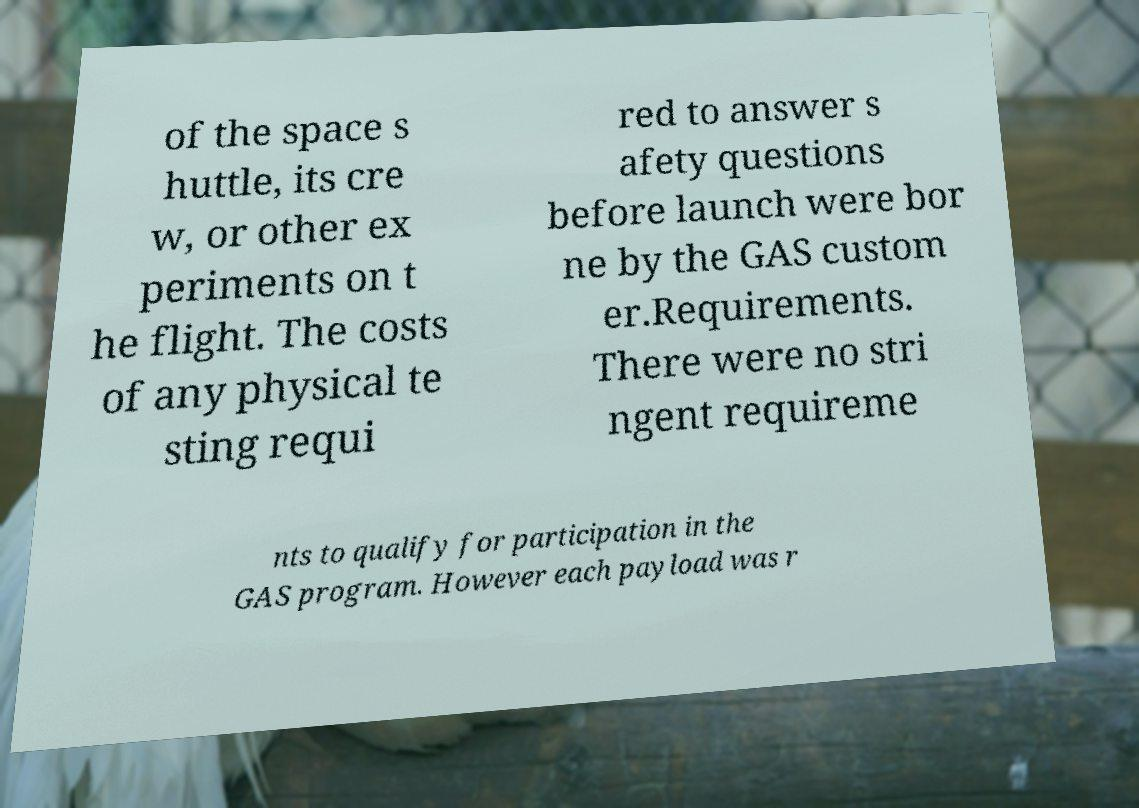I need the written content from this picture converted into text. Can you do that? of the space s huttle, its cre w, or other ex periments on t he flight. The costs of any physical te sting requi red to answer s afety questions before launch were bor ne by the GAS custom er.Requirements. There were no stri ngent requireme nts to qualify for participation in the GAS program. However each payload was r 